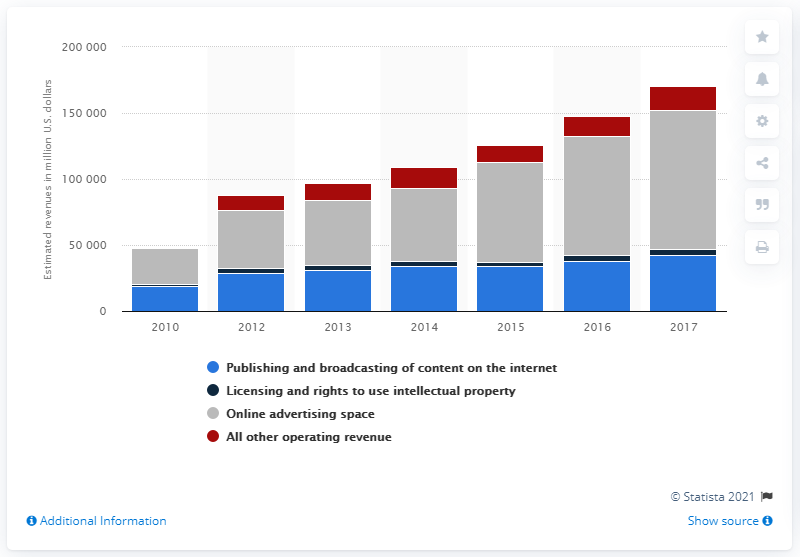Mention a couple of crucial points in this snapshot. In the most recent year, the amount of money made by companies in the internet publishing, broadcasting, and web search portal services was 105,190. 